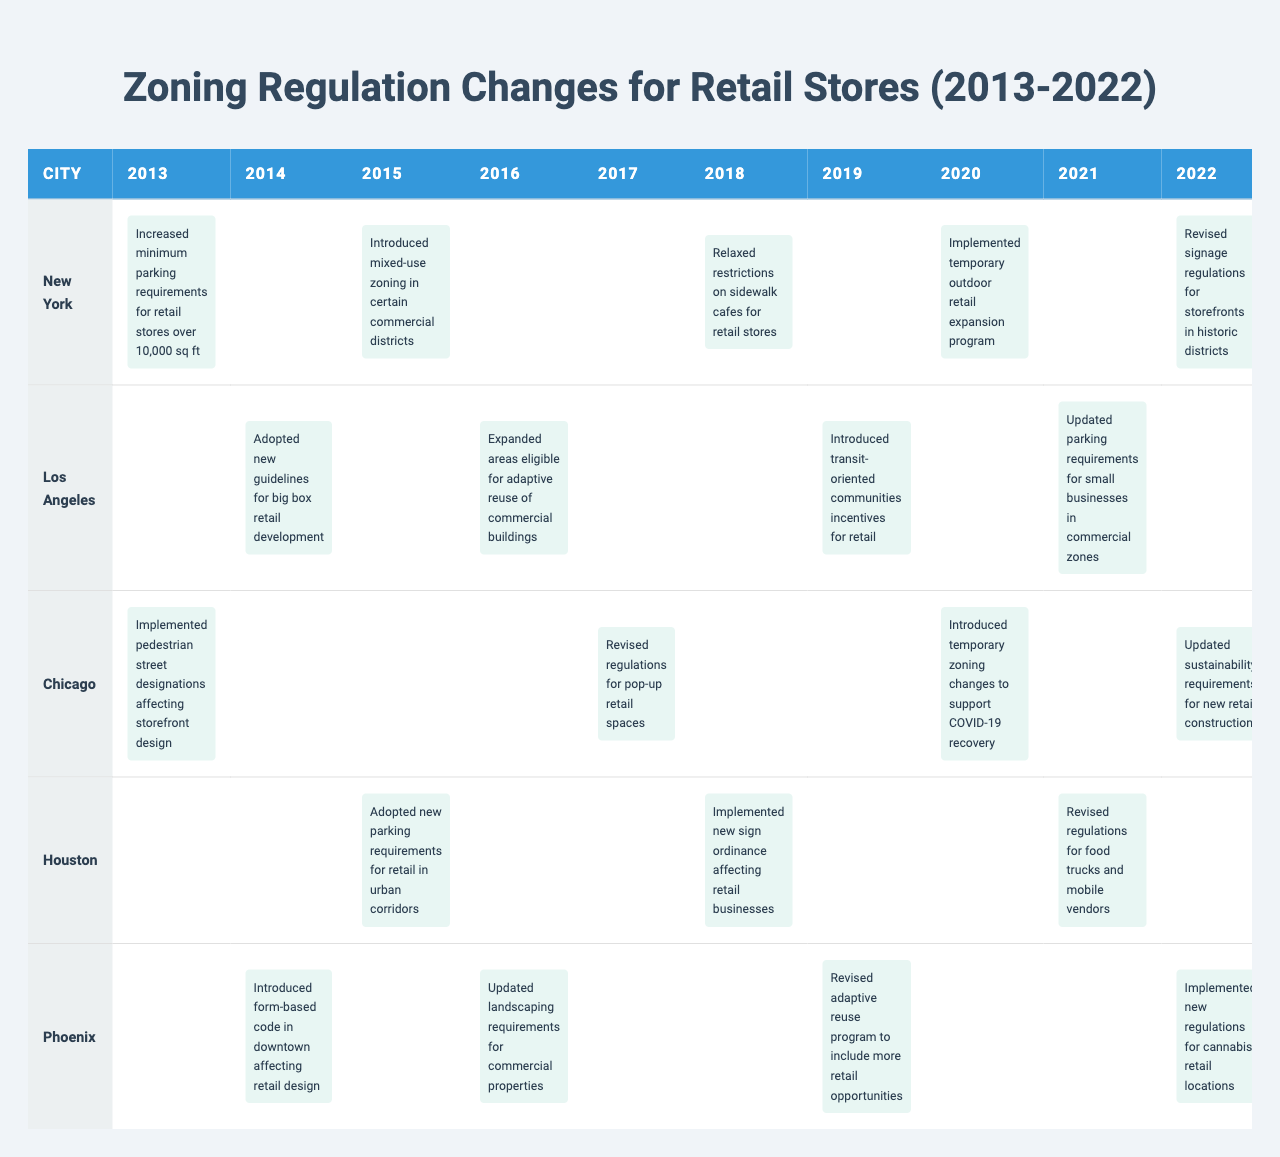What zoning regulation change was introduced in New York in 2018? The table shows that in 2018, New York relaxed restrictions on sidewalk cafes for retail stores.
Answer: Relaxed restrictions on sidewalk cafes What year did Los Angeles adopt new guidelines for big box retail development? According to the table, Los Angeles adopted these guidelines in 2014.
Answer: 2014 How many regulation changes affecting retail stores were implemented in Chicago from 2013 to 2022? Chicago had a total of four regulation changes listed in the table: in 2013, 2017, 2020, and 2022.
Answer: 4 Which city had regulation changes regarding cannabis retail locations, and in what year? The table indicates that Phoenix implemented new regulations for cannabis retail locations in 2022.
Answer: Phoenix, 2022 In how many years did Houston enact regulations affecting parking for retail stores? Houston enacted parking regulations in 2015 and 2018, which totals two years.
Answer: 2 Between 2013 and 2022, which city introduced the most zoning regulation changes? By comparing the counts of changes, New York had five changes whereas others had fewer, indicating it had the most.
Answer: New York Did Chicago have any zoning regulations affecting pop-up retail spaces? The table confirms that Chicago revised regulations for pop-up retail spaces in 2017.
Answer: Yes What were the zoning changes for retail stores in Phoenix between 2016 and 2022? The changes included updating landscaping requirements in 2016, revising the adaptive reuse program in 2019, and implementing regulations for cannabis retail in 2022.
Answer: Three changes What is the average year when significant zoning changes for retail stores occurred in Los Angeles? The years for changes in Los Angeles are 2014, 2016, 2019, and 2021. The average year is (2014 + 2016 + 2019 + 2021) / 4 = 2017.5.
Answer: 2017.5 In what year did New York implement a temporary outdoor retail expansion program? The table indicates that New York implemented this program in 2020.
Answer: 2020 